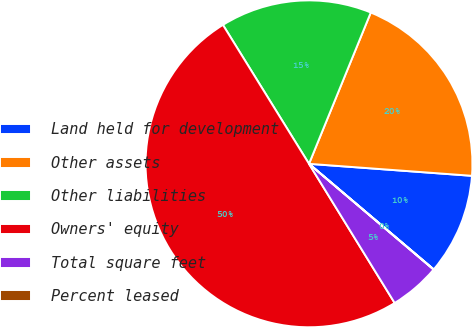Convert chart. <chart><loc_0><loc_0><loc_500><loc_500><pie_chart><fcel>Land held for development<fcel>Other assets<fcel>Other liabilities<fcel>Owners' equity<fcel>Total square feet<fcel>Percent leased<nl><fcel>10.01%<fcel>20.0%<fcel>15.0%<fcel>49.96%<fcel>5.02%<fcel>0.02%<nl></chart> 